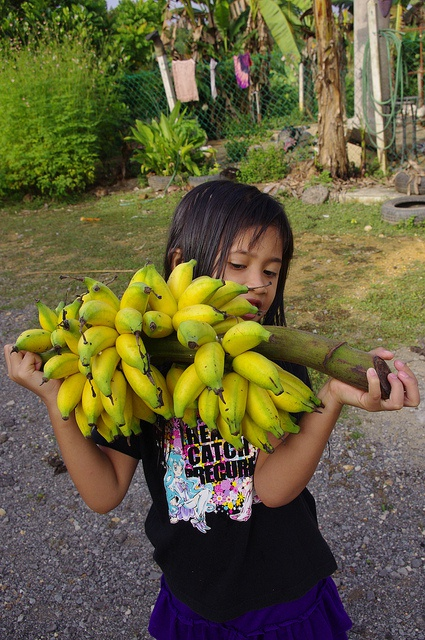Describe the objects in this image and their specific colors. I can see people in darkgreen, black, brown, and maroon tones and banana in darkgreen, olive, gold, and black tones in this image. 